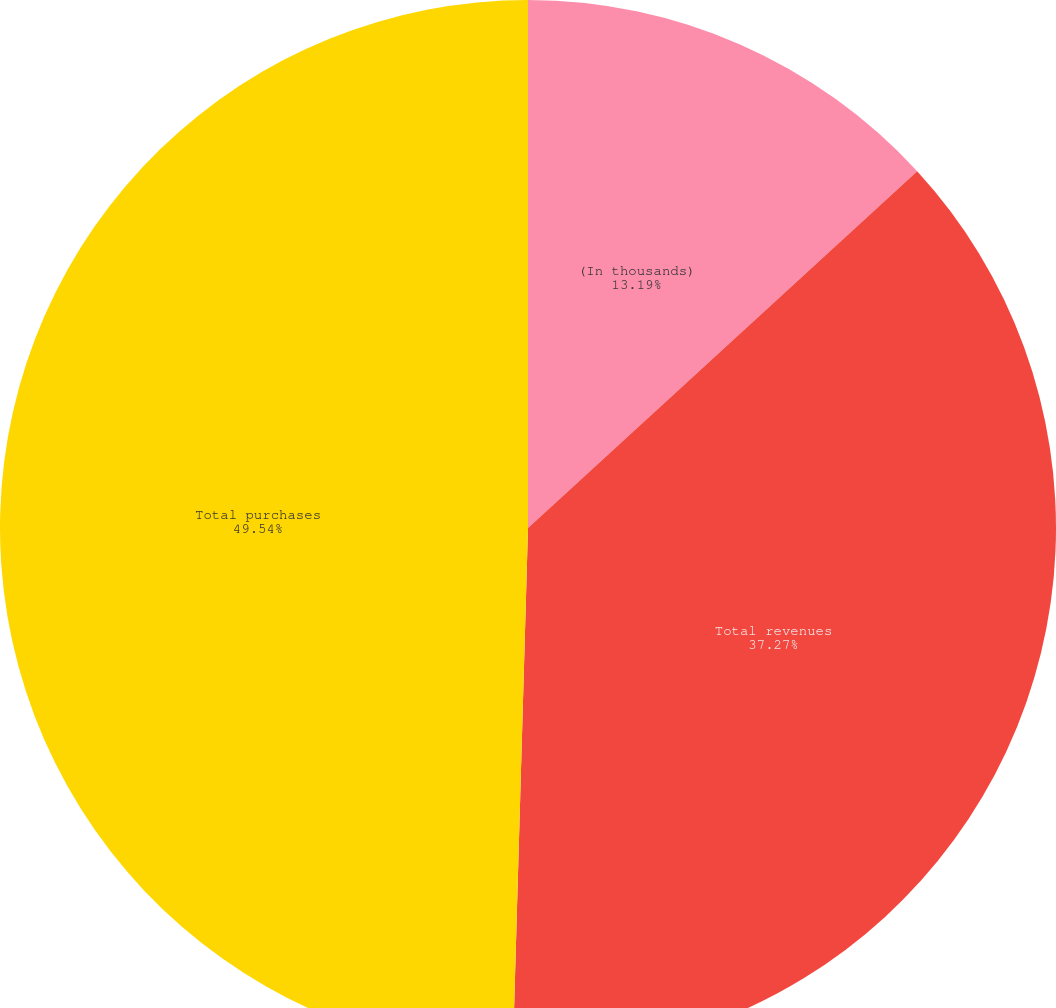<chart> <loc_0><loc_0><loc_500><loc_500><pie_chart><fcel>(In thousands)<fcel>Total revenues<fcel>Total purchases<nl><fcel>13.19%<fcel>37.27%<fcel>49.54%<nl></chart> 